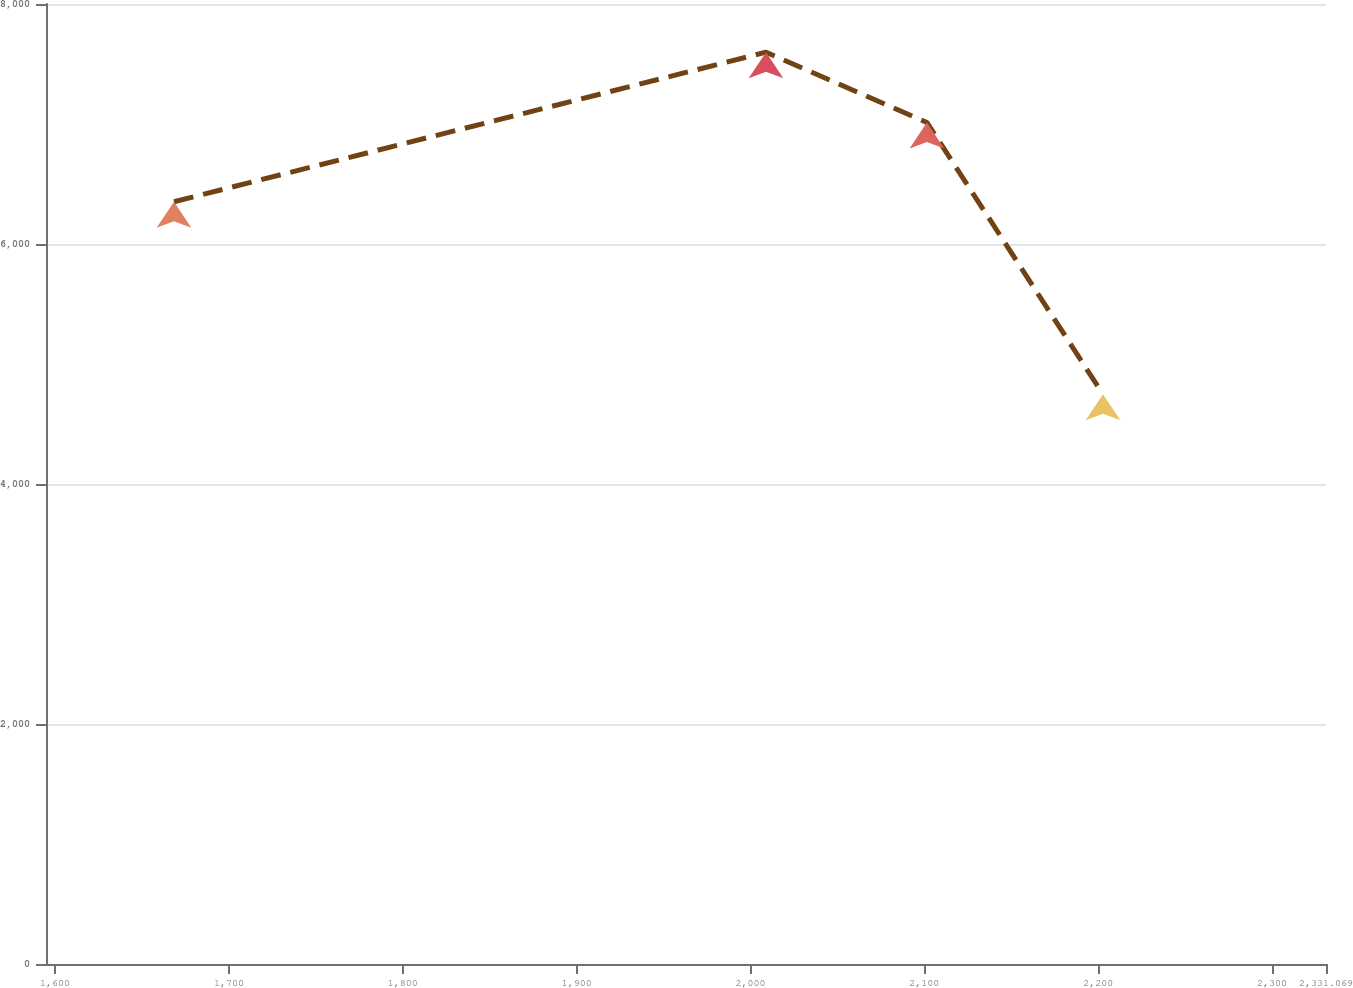Convert chart to OTSL. <chart><loc_0><loc_0><loc_500><loc_500><line_chart><ecel><fcel>Unnamed: 1<nl><fcel>1668.39<fcel>6352.3<nl><fcel>2008.94<fcel>7598.53<nl><fcel>2101.49<fcel>7013.18<nl><fcel>2202.79<fcel>4748.04<nl><fcel>2404.7<fcel>1626.75<nl></chart> 